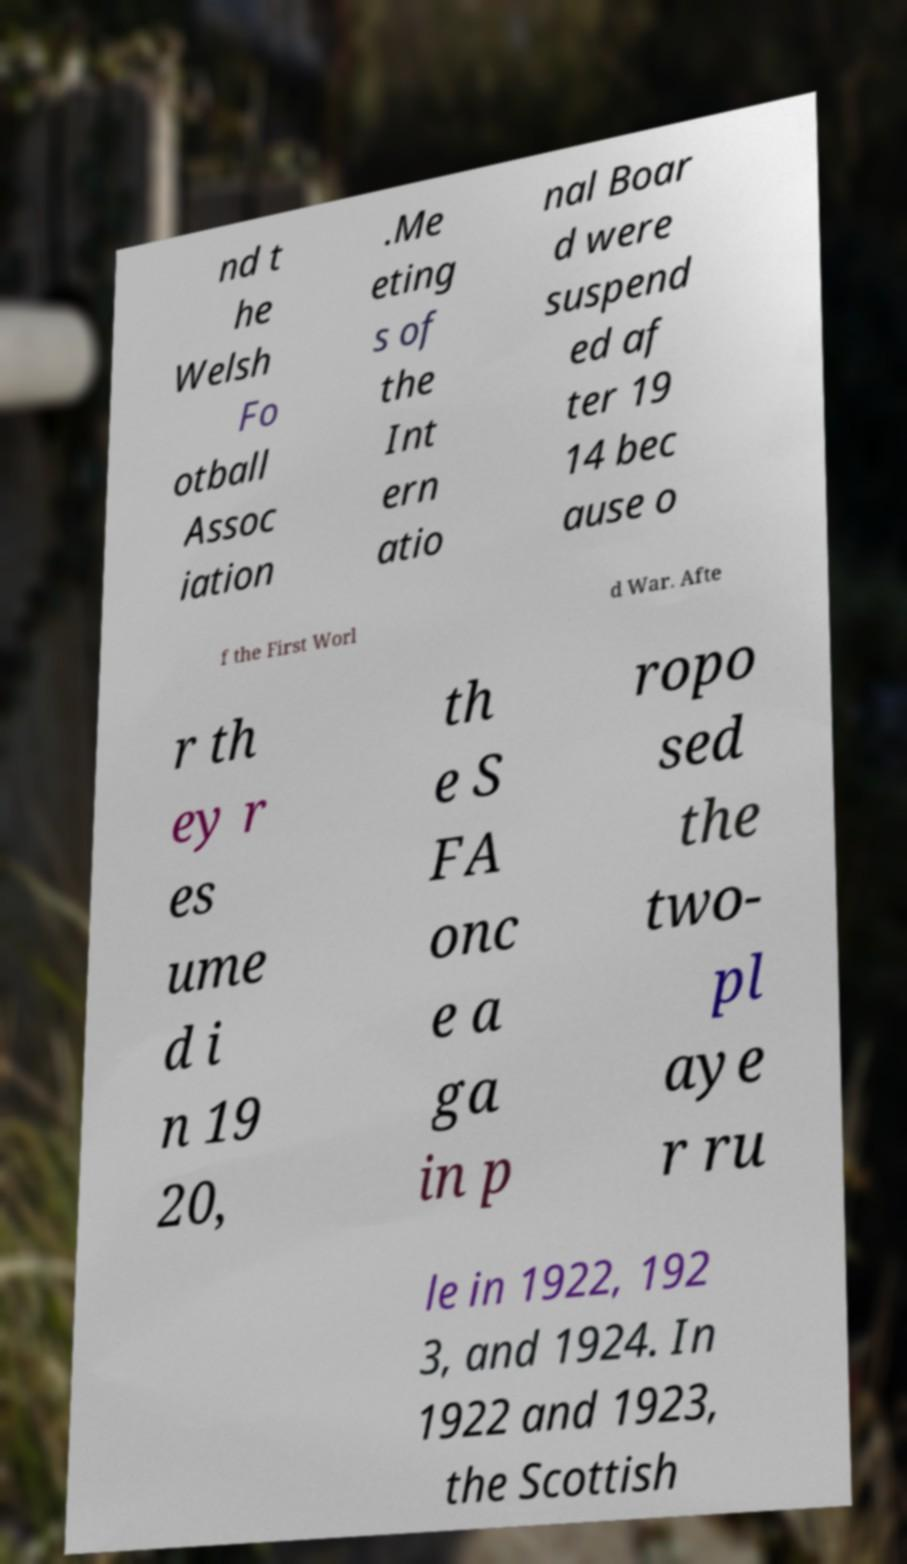What messages or text are displayed in this image? I need them in a readable, typed format. nd t he Welsh Fo otball Assoc iation .Me eting s of the Int ern atio nal Boar d were suspend ed af ter 19 14 bec ause o f the First Worl d War. Afte r th ey r es ume d i n 19 20, th e S FA onc e a ga in p ropo sed the two- pl aye r ru le in 1922, 192 3, and 1924. In 1922 and 1923, the Scottish 